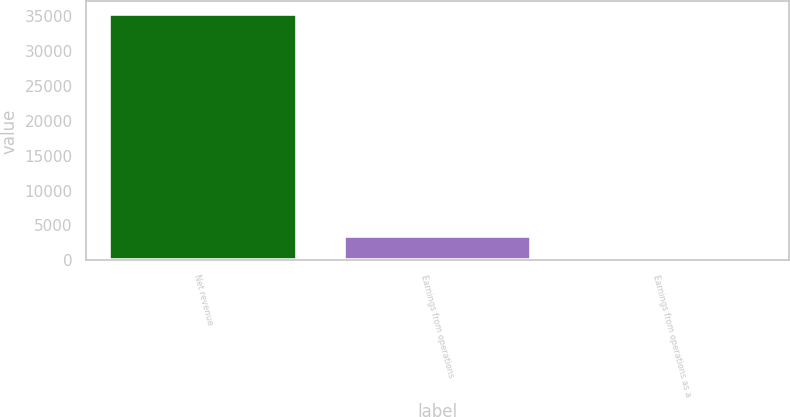Convert chart to OTSL. <chart><loc_0><loc_0><loc_500><loc_500><bar_chart><fcel>Net revenue<fcel>Earnings from operations<fcel>Earnings from operations as a<nl><fcel>35305<fcel>3534.73<fcel>4.7<nl></chart> 